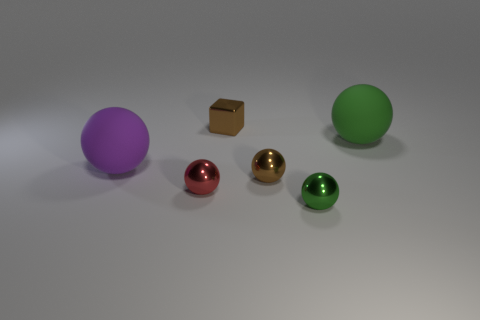Subtract 1 balls. How many balls are left? 4 Subtract all blue spheres. Subtract all yellow cylinders. How many spheres are left? 5 Add 3 green cubes. How many objects exist? 9 Subtract all spheres. How many objects are left? 1 Add 2 large green things. How many large green things are left? 3 Add 2 tiny brown matte things. How many tiny brown matte things exist? 2 Subtract 1 brown blocks. How many objects are left? 5 Subtract all big objects. Subtract all small red metallic spheres. How many objects are left? 3 